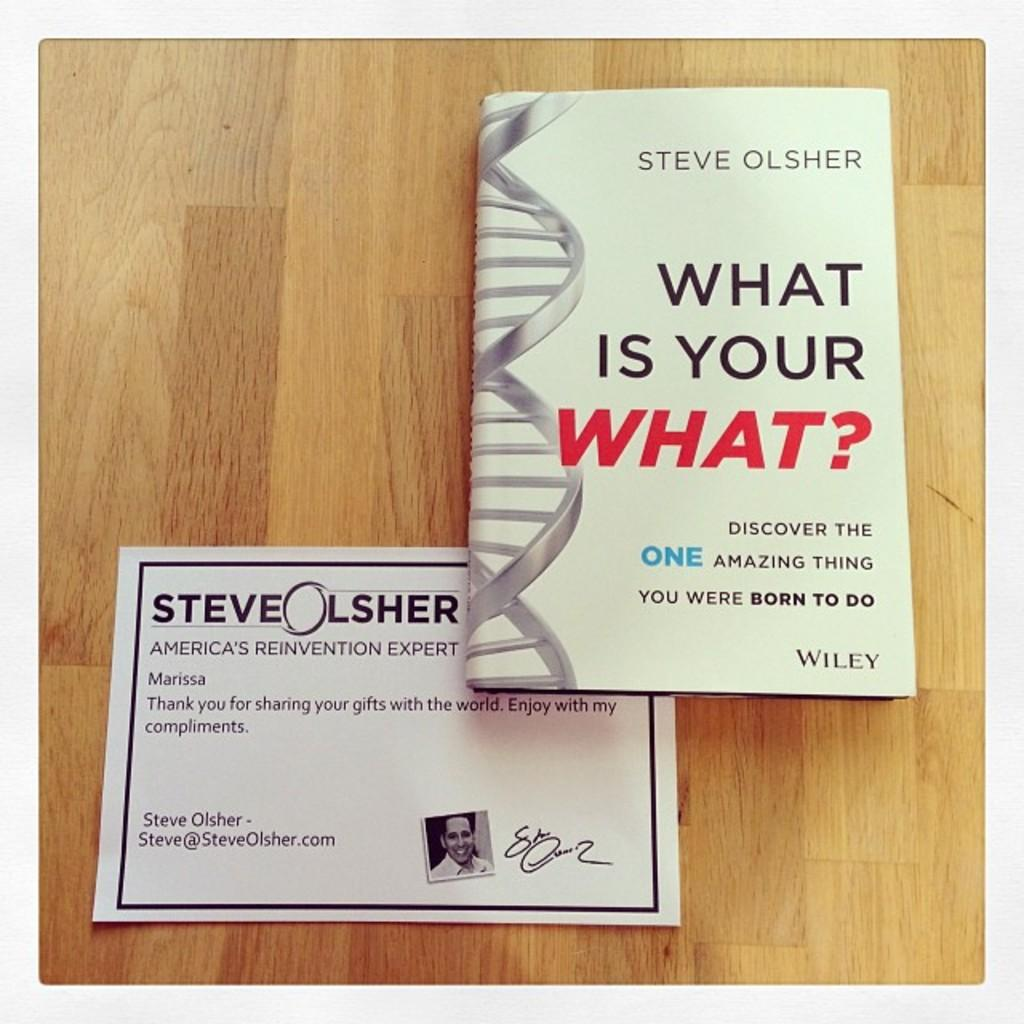<image>
Provide a brief description of the given image. A book by Steve Olsher is on a table with a printed note from the author. 